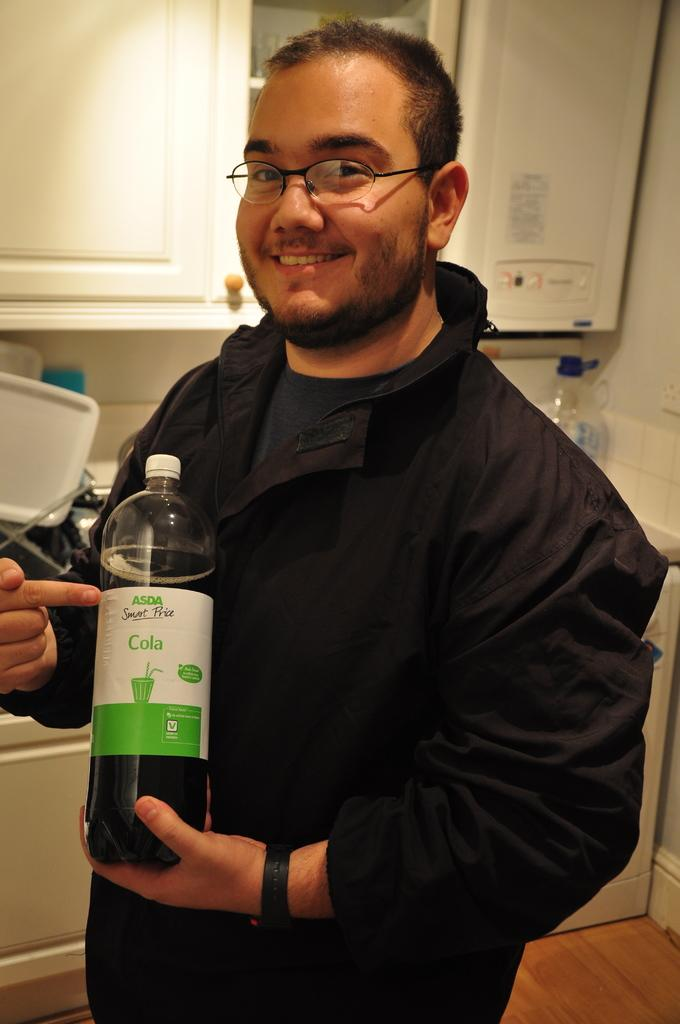What is the main subject of the image? There is a man standing in the center of the image. What is the man wearing? The man is wearing a black shirt. What is the man holding in his hand? The man is holding a cola bottle in his hand. What can be seen in the background of the image? There is a cupboard and a counter table in the background. How many times has the man blinked his eye in the image? The image does not show the man blinking his eye, so it is not possible to determine how many times he blinked. 